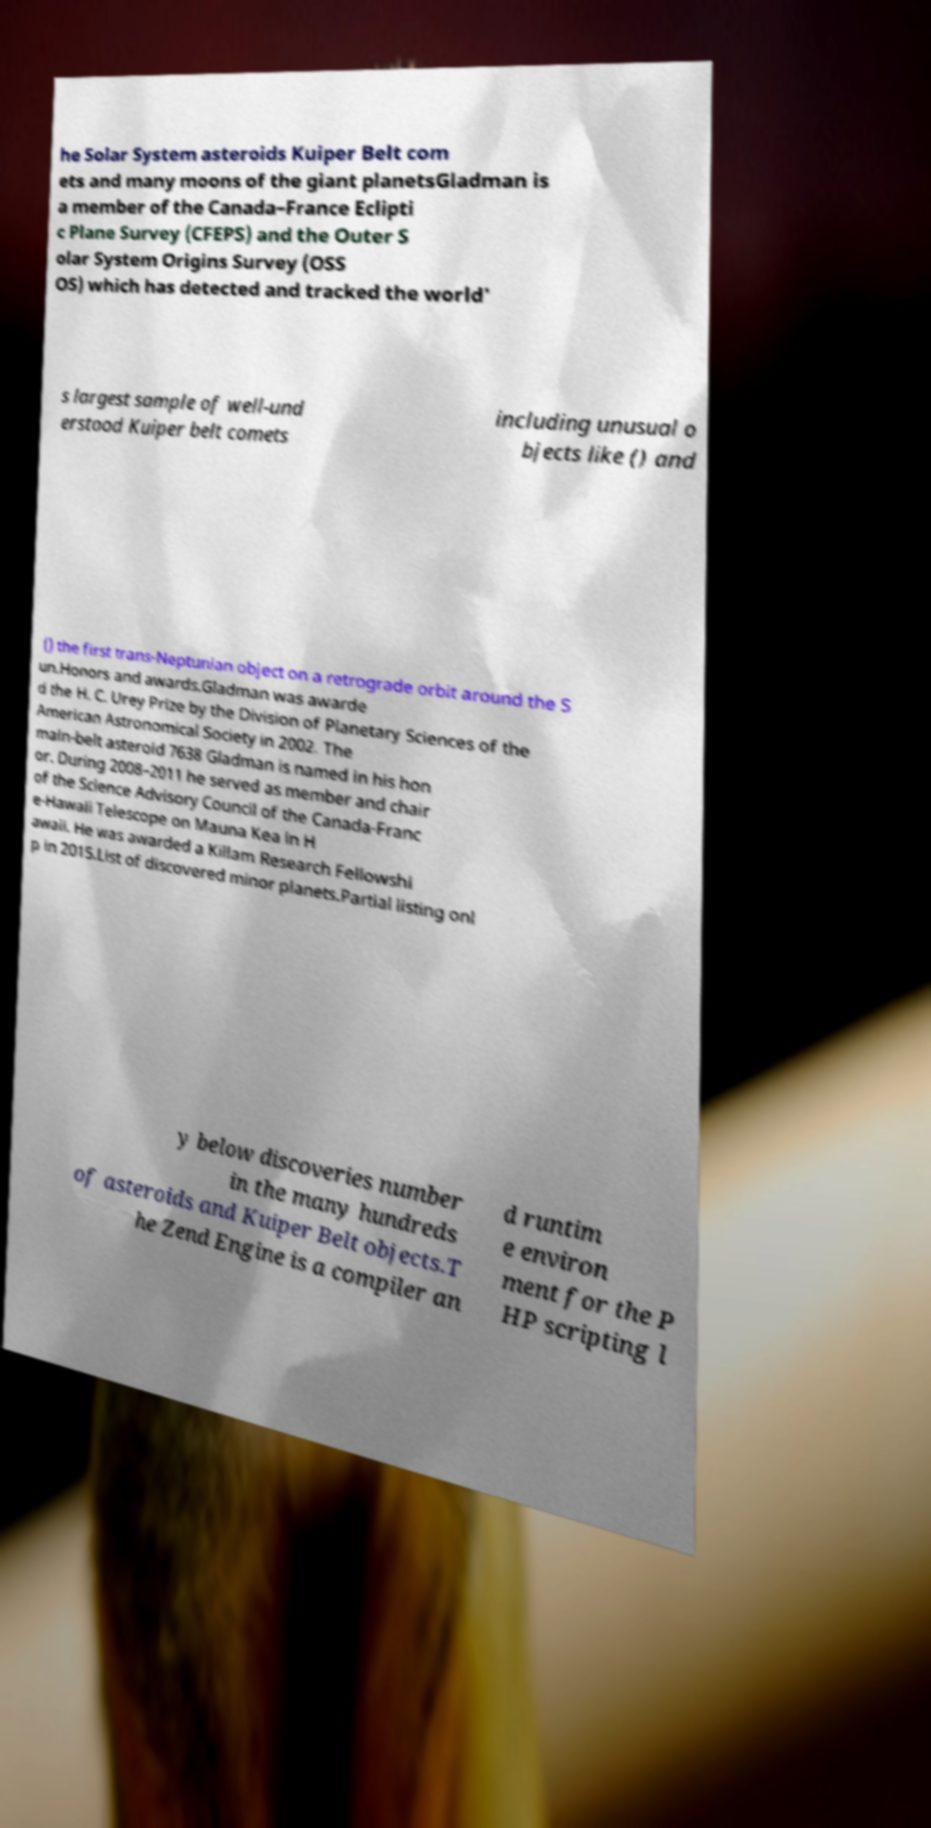Please read and relay the text visible in this image. What does it say? he Solar System asteroids Kuiper Belt com ets and many moons of the giant planetsGladman is a member of the Canada–France Eclipti c Plane Survey (CFEPS) and the Outer S olar System Origins Survey (OSS OS) which has detected and tracked the world' s largest sample of well-und erstood Kuiper belt comets including unusual o bjects like () and () the first trans-Neptunian object on a retrograde orbit around the S un.Honors and awards.Gladman was awarde d the H. C. Urey Prize by the Division of Planetary Sciences of the American Astronomical Society in 2002. The main-belt asteroid 7638 Gladman is named in his hon or. During 2008–2011 he served as member and chair of the Science Advisory Council of the Canada-Franc e-Hawaii Telescope on Mauna Kea in H awaii. He was awarded a Killam Research Fellowshi p in 2015.List of discovered minor planets.Partial listing onl y below discoveries number in the many hundreds of asteroids and Kuiper Belt objects.T he Zend Engine is a compiler an d runtim e environ ment for the P HP scripting l 